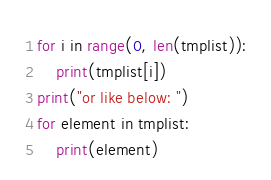Convert code to text. <code><loc_0><loc_0><loc_500><loc_500><_Python_>for i in range(0, len(tmplist)):
    print(tmplist[i])
print("or like below: ")
for element in tmplist:
    print(element)
</code> 